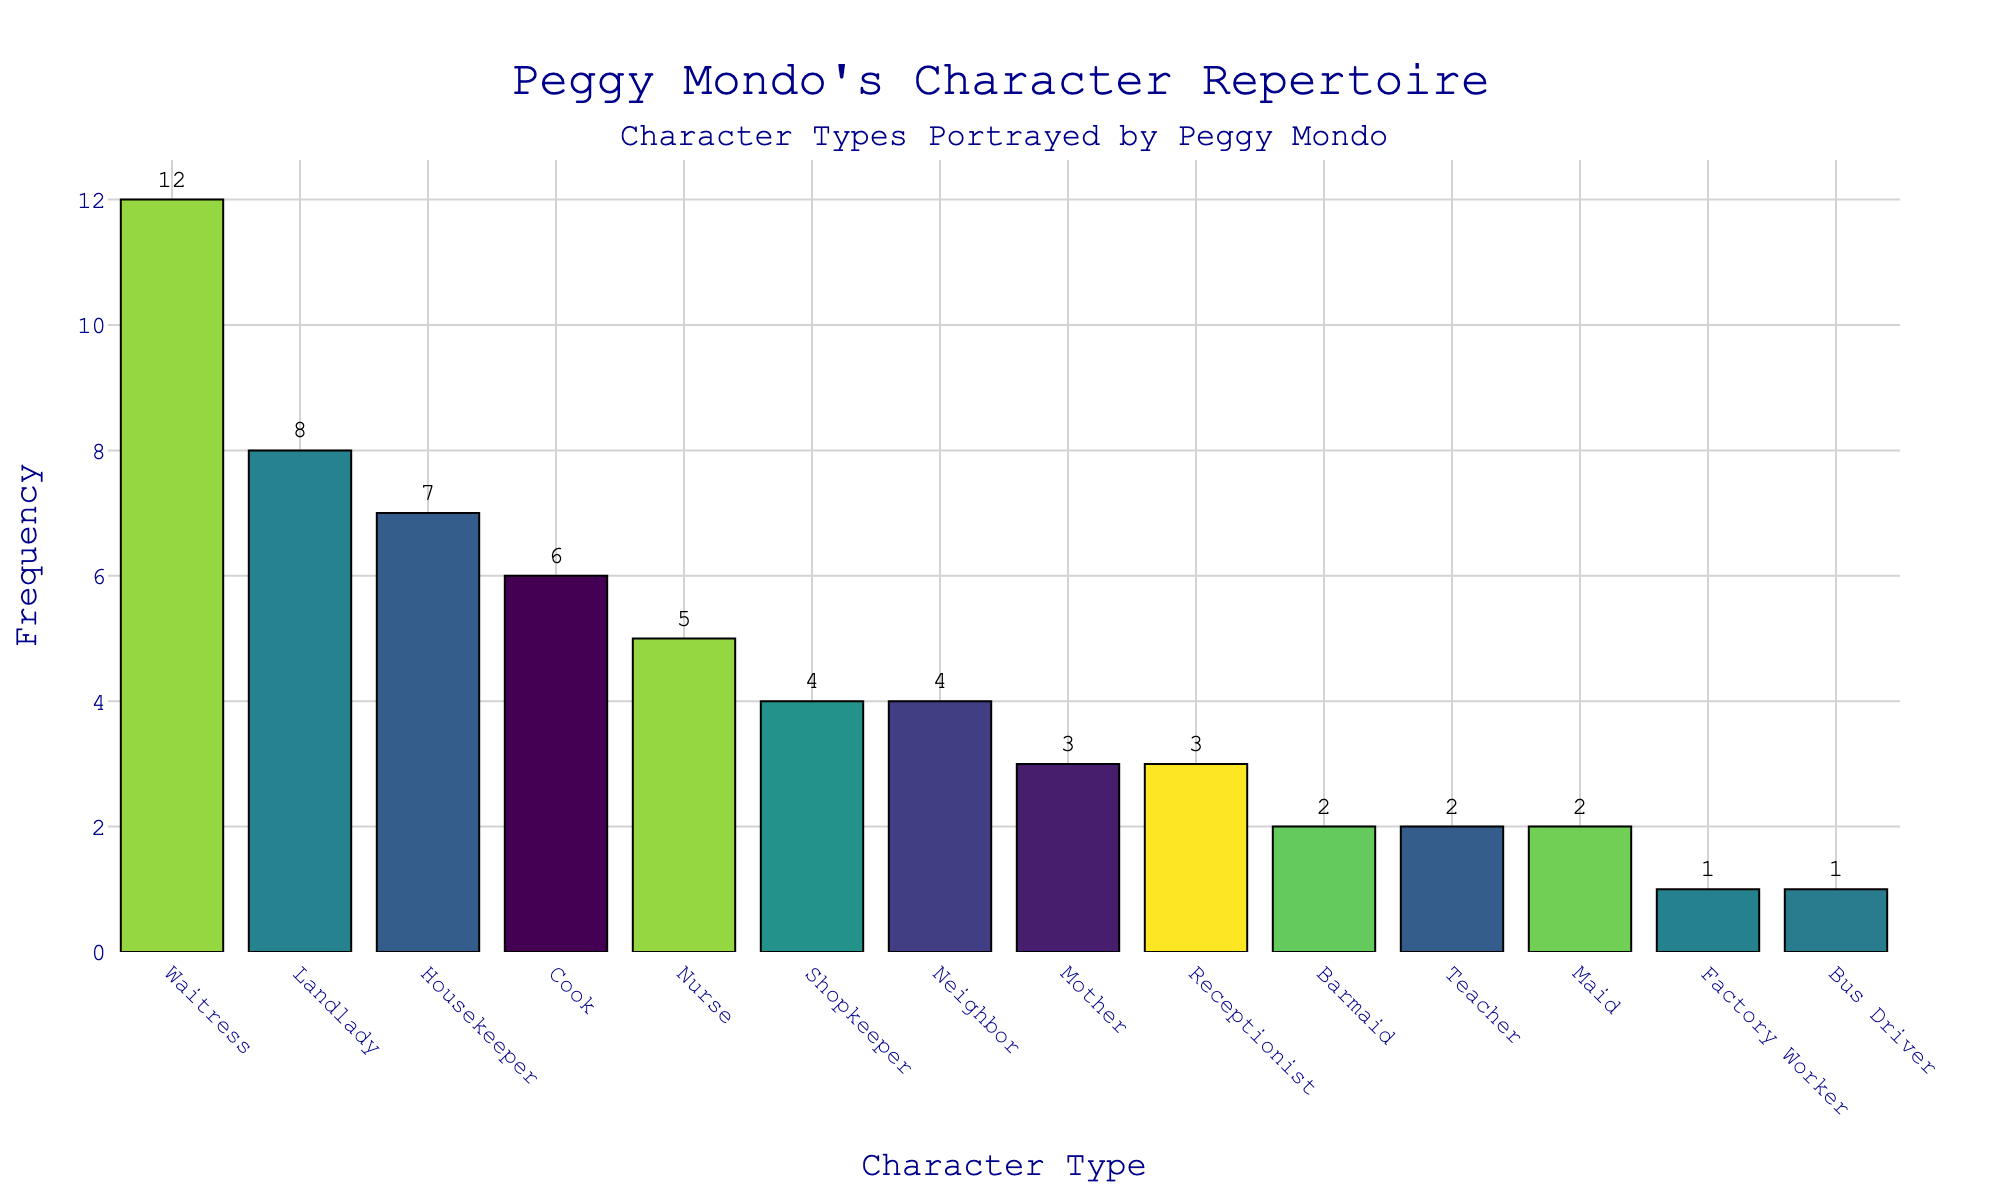what character type did Peggy Mondo portray the most? To determine the most portrayed character type, we look for the bar with the greatest height. The highest bar represents "Waitress" with a frequency of 12.
Answer: Waitress how many times did Peggy Mondo play roles as a Cook and Landlady combined? Add the frequencies of the character types "Cook" (6) and "Landlady" (8). The sum is 6 + 8.
Answer: 14 which character type has the least frequency and what is its value? Identify the smallest bar in the chart. The shortest bar corresponds to "Factory Worker" and "Bus Driver," each with a frequency of 1.
Answer: Factory Worker and Bus Driver, 1 how many character types did Peggy Mondo portray precisely 4 times? Count the bars with a frequency of 4. The bars for "Shopkeeper" and "Neighbor" both have a frequency of 4.
Answer: 2 did Peggy Mondo portray Housekeeper roles more frequently than Nurse roles? Compare the heights of the bars for "Housekeeper" and "Nurse." "Housekeeper" has a frequency of 7 while "Nurse" has a frequency of 5.
Answer: Yes what's the total number of roles played by Peggy Mondo listed on the chart? Sum the frequencies of all listed character types. Adding up these frequencies: 12 + 8 + 7 + 6 + 5 + 4 + 4 + 3 + 3 + 2 + 2 + 2 + 1 + 1 = 60.
Answer: 60 what is the average frequency of the roles portrayed by Peggy Mondo, rounded to the nearest whole number? Calculate the mean value by dividing the total frequency count by the number of unique character types (14). Total frequency is 60; average = 60 / 14 ≈ 4.29, rounded to the nearest whole number is 4.
Answer: 4 which character type did Peggy Mondo play more often, Neighbor or Mother? Compare the heights of the bars for "Neighbor" and "Mother." "Neighbor" has a frequency of 4, while "Mother" has a frequency of 3.
Answer: Neighbor did Peggy Mondo portray roles as a Receptionist more frequently than a Bus Driver? Compare the heights of the bars for "Receptionist" and "Bus Driver." "Receptionist" has a frequency of 3, while "Bus Driver" has a frequency of 1.
Answer: Yes how does the frequency of roles as a Shopkeeper compare to those as a Teacher? Compare the heights of the bars for "Shopkeeper" and "Teacher." Both have the same frequency of 4 and 2 respectively.
Answer: Shopkeeper has a higher frequency than Teacher 